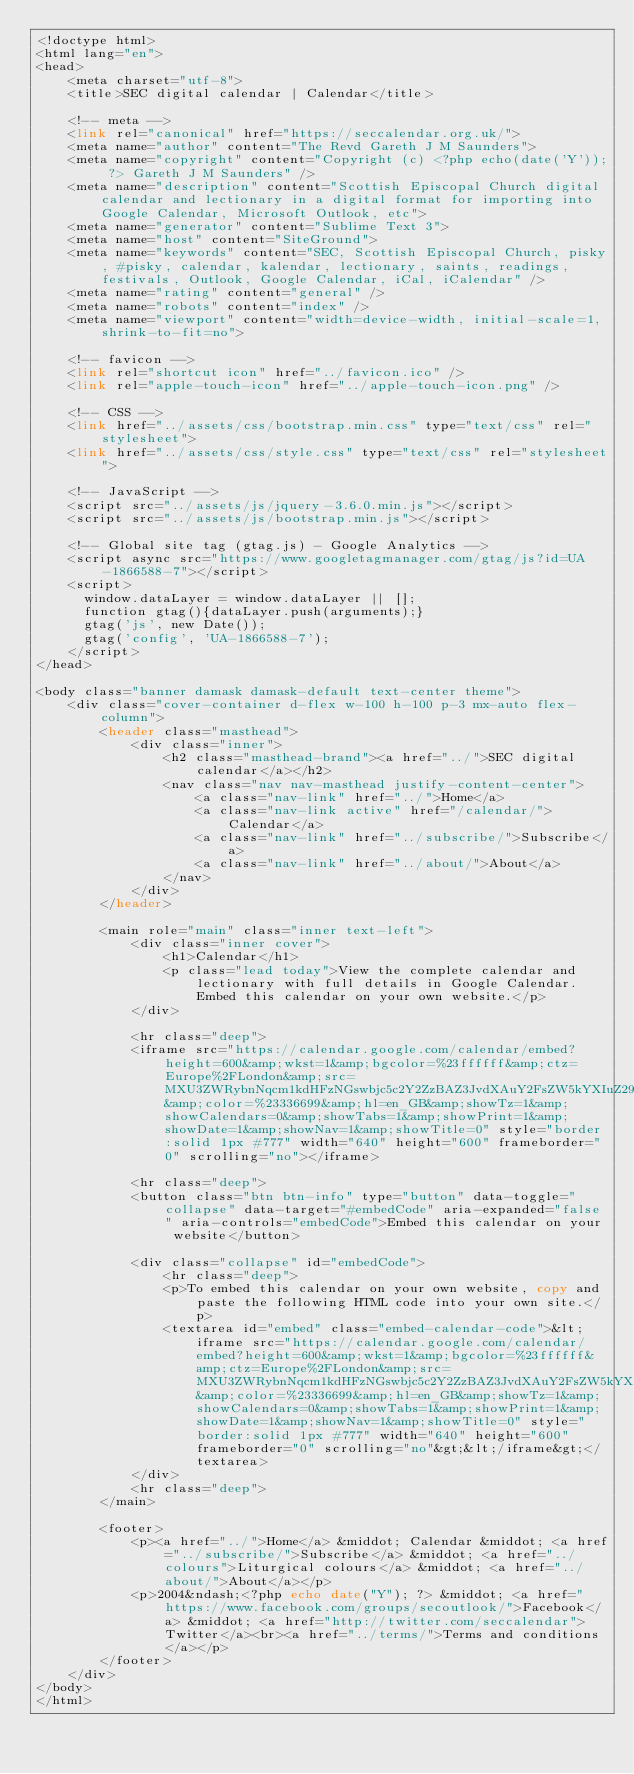Convert code to text. <code><loc_0><loc_0><loc_500><loc_500><_PHP_><!doctype html>
<html lang="en">
<head>
    <meta charset="utf-8">
    <title>SEC digital calendar | Calendar</title>

    <!-- meta -->
    <link rel="canonical" href="https://seccalendar.org.uk/">
    <meta name="author" content="The Revd Gareth J M Saunders">
    <meta name="copyright" content="Copyright (c) <?php echo(date('Y')); ?> Gareth J M Saunders" />
    <meta name="description" content="Scottish Episcopal Church digital calendar and lectionary in a digital format for importing into Google Calendar, Microsoft Outlook, etc">
    <meta name="generator" content="Sublime Text 3">
    <meta name="host" content="SiteGround">
    <meta name="keywords" content="SEC, Scottish Episcopal Church, pisky, #pisky, calendar, kalendar, lectionary, saints, readings, festivals, Outlook, Google Calendar, iCal, iCalendar" />
    <meta name="rating" content="general" />
    <meta name="robots" content="index" />
    <meta name="viewport" content="width=device-width, initial-scale=1, shrink-to-fit=no">

    <!-- favicon -->
    <link rel="shortcut icon" href="../favicon.ico" />
    <link rel="apple-touch-icon" href="../apple-touch-icon.png" />

    <!-- CSS -->
    <link href="../assets/css/bootstrap.min.css" type="text/css" rel="stylesheet">
    <link href="../assets/css/style.css" type="text/css" rel="stylesheet">

    <!-- JavaScript -->
    <script src="../assets/js/jquery-3.6.0.min.js"></script>
    <script src="../assets/js/bootstrap.min.js"></script>

    <!-- Global site tag (gtag.js) - Google Analytics -->
    <script async src="https://www.googletagmanager.com/gtag/js?id=UA-1866588-7"></script>
    <script>
      window.dataLayer = window.dataLayer || [];
      function gtag(){dataLayer.push(arguments);}
      gtag('js', new Date());
      gtag('config', 'UA-1866588-7');
    </script>
</head>

<body class="banner damask damask-default text-center theme">
    <div class="cover-container d-flex w-100 h-100 p-3 mx-auto flex-column">
        <header class="masthead">
            <div class="inner">
                <h2 class="masthead-brand"><a href="../">SEC digital calendar</a></h2>
                <nav class="nav nav-masthead justify-content-center">
                    <a class="nav-link" href="../">Home</a>
                    <a class="nav-link active" href="/calendar/">Calendar</a>
                    <a class="nav-link" href="../subscribe/">Subscribe</a>
                    <a class="nav-link" href="../about/">About</a>
                </nav>
            </div>
        </header>

        <main role="main" class="inner text-left">
            <div class="inner cover">
                <h1>Calendar</h1>
                <p class="lead today">View the complete calendar and lectionary with full details in Google Calendar. Embed this calendar on your own website.</p>
            </div>

            <hr class="deep">
            <iframe src="https://calendar.google.com/calendar/embed?height=600&amp;wkst=1&amp;bgcolor=%23ffffff&amp;ctz=Europe%2FLondon&amp;src=MXU3ZWRybnNqcm1kdHFzNGswbjc5c2Y2ZzBAZ3JvdXAuY2FsZW5kYXIuZ29vZ2xlLmNvbQ&amp;color=%23336699&amp;hl=en_GB&amp;showTz=1&amp;showCalendars=0&amp;showTabs=1&amp;showPrint=1&amp;showDate=1&amp;showNav=1&amp;showTitle=0" style="border:solid 1px #777" width="640" height="600" frameborder="0" scrolling="no"></iframe>

            <hr class="deep">
            <button class="btn btn-info" type="button" data-toggle="collapse" data-target="#embedCode" aria-expanded="false" aria-controls="embedCode">Embed this calendar on your website</button>

            <div class="collapse" id="embedCode">
                <hr class="deep">
                <p>To embed this calendar on your own website, copy and paste the following HTML code into your own site.</p>
                <textarea id="embed" class="embed-calendar-code">&lt;iframe src="https://calendar.google.com/calendar/embed?height=600&amp;wkst=1&amp;bgcolor=%23ffffff&amp;ctz=Europe%2FLondon&amp;src=MXU3ZWRybnNqcm1kdHFzNGswbjc5c2Y2ZzBAZ3JvdXAuY2FsZW5kYXIuZ29vZ2xlLmNvbQ&amp;color=%23336699&amp;hl=en_GB&amp;showTz=1&amp;showCalendars=0&amp;showTabs=1&amp;showPrint=1&amp;showDate=1&amp;showNav=1&amp;showTitle=0" style="border:solid 1px #777" width="640" height="600" frameborder="0" scrolling="no"&gt;&lt;/iframe&gt;</textarea>
            </div>
            <hr class="deep">
        </main>

        <footer>
            <p><a href="../">Home</a> &middot; Calendar &middot; <a href="../subscribe/">Subscribe</a> &middot; <a href="../colours">Liturgical colours</a> &middot; <a href="../about/">About</a></p>
            <p>2004&ndash;<?php echo date("Y"); ?> &middot; <a href="https://www.facebook.com/groups/secoutlook/">Facebook</a> &middot; <a href="http://twitter.com/seccalendar">Twitter</a><br><a href="../terms/">Terms and conditions</a></p>
        </footer>
    </div>
</body>
</html></code> 